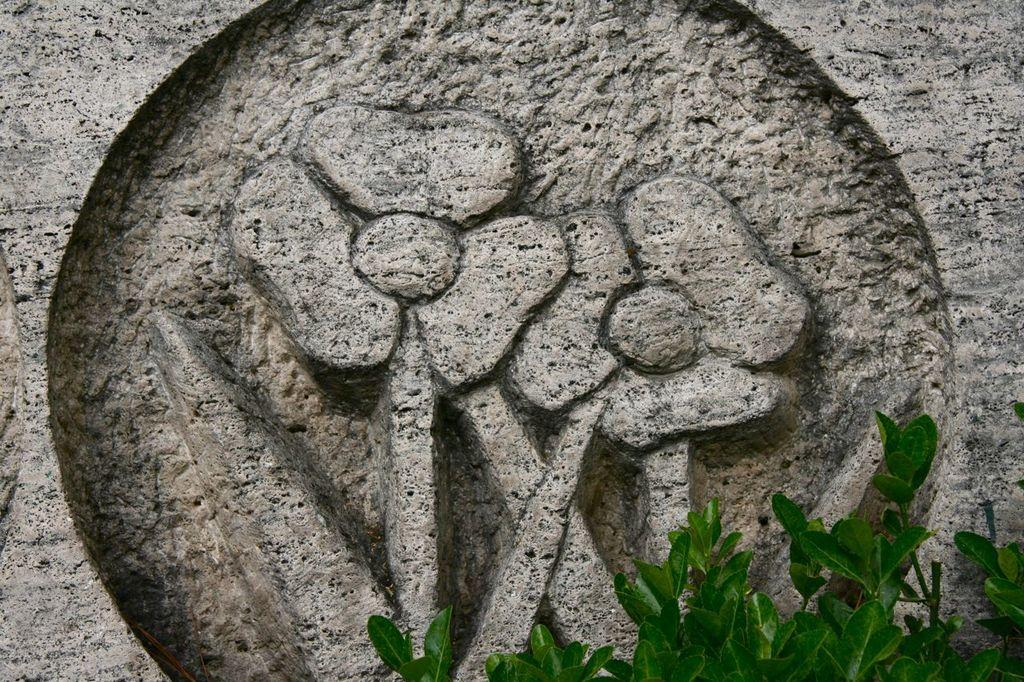What type of living organisms can be seen in the image? Plants can be seen in the image. What can be found on the wall in the image? There is carving on the wall in the image. What type of tent is set up near the plants in the image? There is no tent present in the image; it only features plants and carving on the wall. What type of poison can be seen in the image? There is no poison present in the image; it only features plants and carving on the wall. 